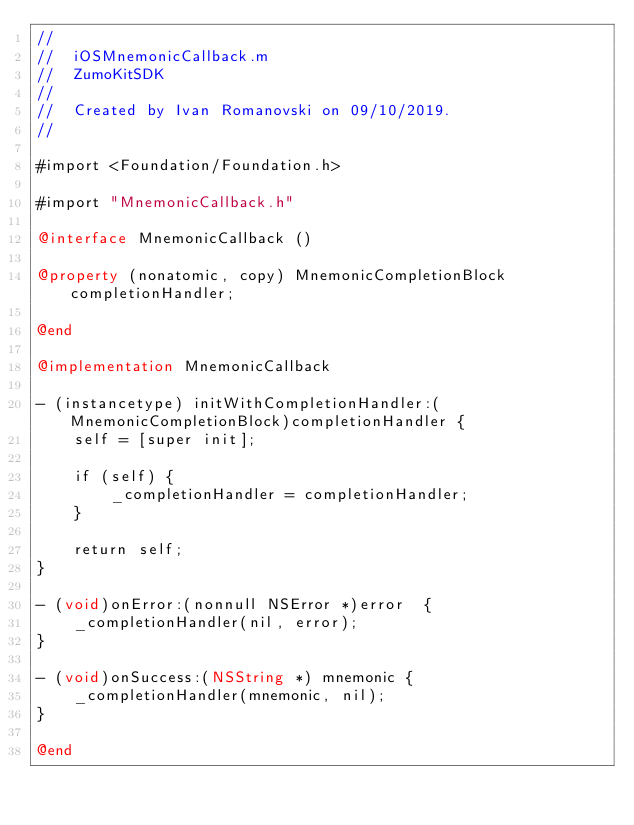Convert code to text. <code><loc_0><loc_0><loc_500><loc_500><_ObjectiveC_>//
//  iOSMnemonicCallback.m
//  ZumoKitSDK
//
//  Created by Ivan Romanovski on 09/10/2019.
//

#import <Foundation/Foundation.h>

#import "MnemonicCallback.h"

@interface MnemonicCallback ()

@property (nonatomic, copy) MnemonicCompletionBlock completionHandler;

@end

@implementation MnemonicCallback

- (instancetype) initWithCompletionHandler:(MnemonicCompletionBlock)completionHandler {
    self = [super init];
    
    if (self) {
        _completionHandler = completionHandler;
    }
    
    return self;
}

- (void)onError:(nonnull NSError *)error  {
    _completionHandler(nil, error);
}

- (void)onSuccess:(NSString *) mnemonic {
    _completionHandler(mnemonic, nil);
}

@end
</code> 